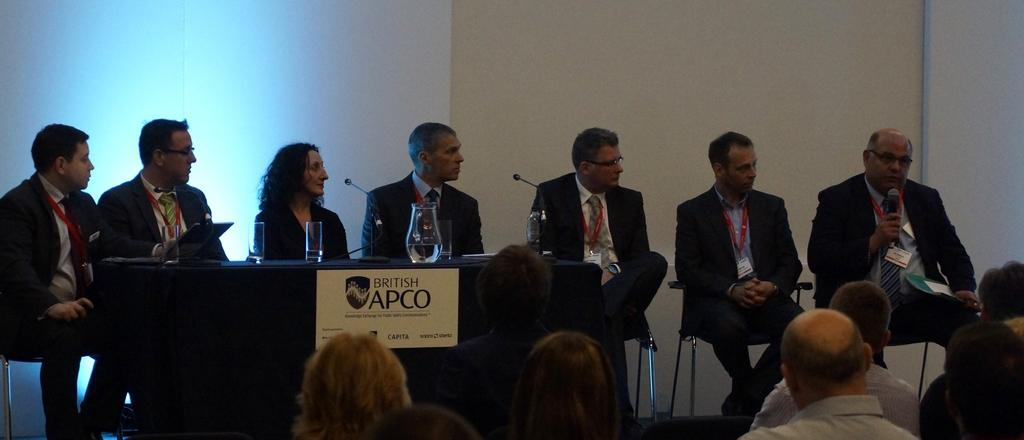What is happening in the image involving a group of people? There is a group of people sitting in front of a stage, and another group of people is listening to a person. What might be the purpose of the stage in the image? The stage in the image might be used for a performance or presentation. What can be found on the table in the image? There are objects placed on a table. What type of crate is being used as a seat by the people sitting in front of the stage? There is no crate present in the image; the people are sitting on chairs or benches. How does the person speaking on the stage make the audience laugh? The image does not provide information about the audience's reaction or the content of the speech, so it cannot be determined if the audience is laughing. 